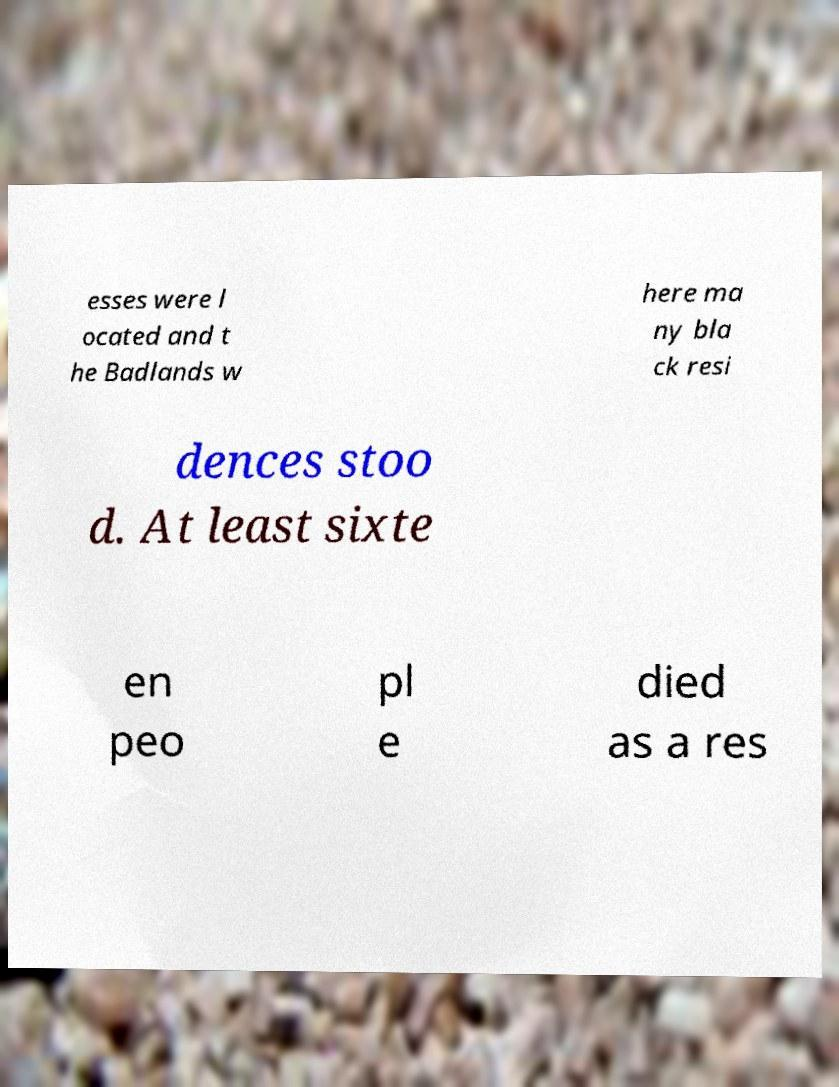There's text embedded in this image that I need extracted. Can you transcribe it verbatim? esses were l ocated and t he Badlands w here ma ny bla ck resi dences stoo d. At least sixte en peo pl e died as a res 